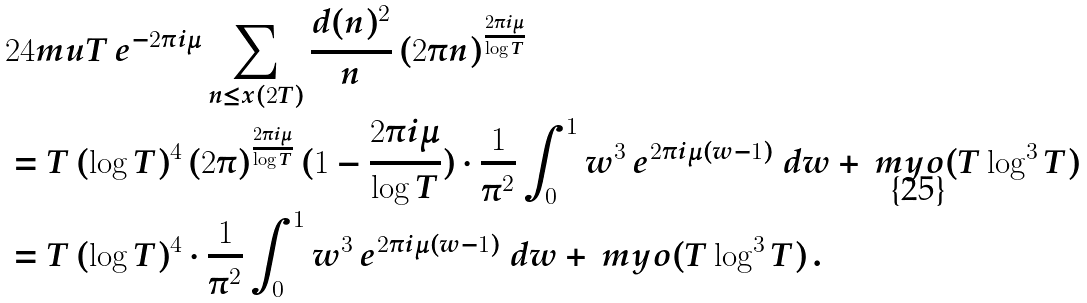Convert formula to latex. <formula><loc_0><loc_0><loc_500><loc_500>& 2 4 m u T \, e ^ { - 2 \pi i \mu } \sum _ { n \leq x ( 2 T ) } \frac { d ( n ) ^ { 2 } } { n } \, ( 2 \pi n ) ^ { \frac { 2 \pi i \mu } { \log T } } \\ & = T \, ( \log T ) ^ { 4 } \, ( 2 \pi ) ^ { \frac { 2 \pi i \mu } { \log T } } \, ( 1 - \frac { 2 \pi i \mu } { \log T } ) \cdot \frac { 1 } { \pi ^ { 2 } } \int _ { 0 } ^ { 1 } w ^ { 3 } \, e ^ { 2 \pi i \mu ( w - 1 ) } \ d w + \ m y o ( T \log ^ { 3 } T ) \\ & = T \, ( \log T ) ^ { 4 } \cdot \frac { 1 } { \pi ^ { 2 } } \int _ { 0 } ^ { 1 } w ^ { 3 } \, e ^ { 2 \pi i \mu ( w - 1 ) } \ d w + \ m y o ( T \log ^ { 3 } T ) \, .</formula> 